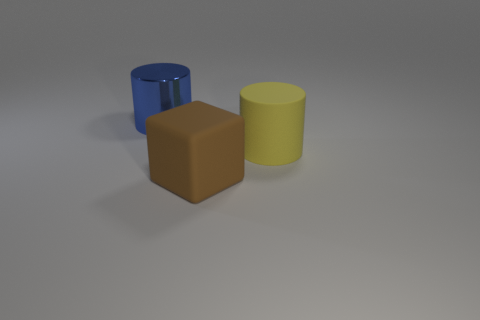There is a yellow object that is the same size as the blue metal cylinder; what is its shape?
Provide a succinct answer. Cylinder. There is a big yellow rubber cylinder; are there any matte objects in front of it?
Make the answer very short. Yes. Is there another rubber thing that has the same shape as the blue object?
Provide a short and direct response. Yes. There is a rubber object that is in front of the large matte cylinder; is it the same shape as the thing on the left side of the big cube?
Give a very brief answer. No. Are there any cyan rubber cubes of the same size as the blue metallic thing?
Your answer should be very brief. No. Is the number of blue cylinders in front of the large yellow rubber thing the same as the number of big yellow matte cylinders that are left of the large brown matte cube?
Offer a very short reply. Yes. Are the cylinder that is in front of the big blue shiny cylinder and the big cylinder that is left of the brown rubber cube made of the same material?
Provide a short and direct response. No. What material is the large brown object?
Provide a short and direct response. Rubber. How many other objects are there of the same color as the matte block?
Offer a very short reply. 0. Is the color of the big shiny thing the same as the big rubber block?
Keep it short and to the point. No. 